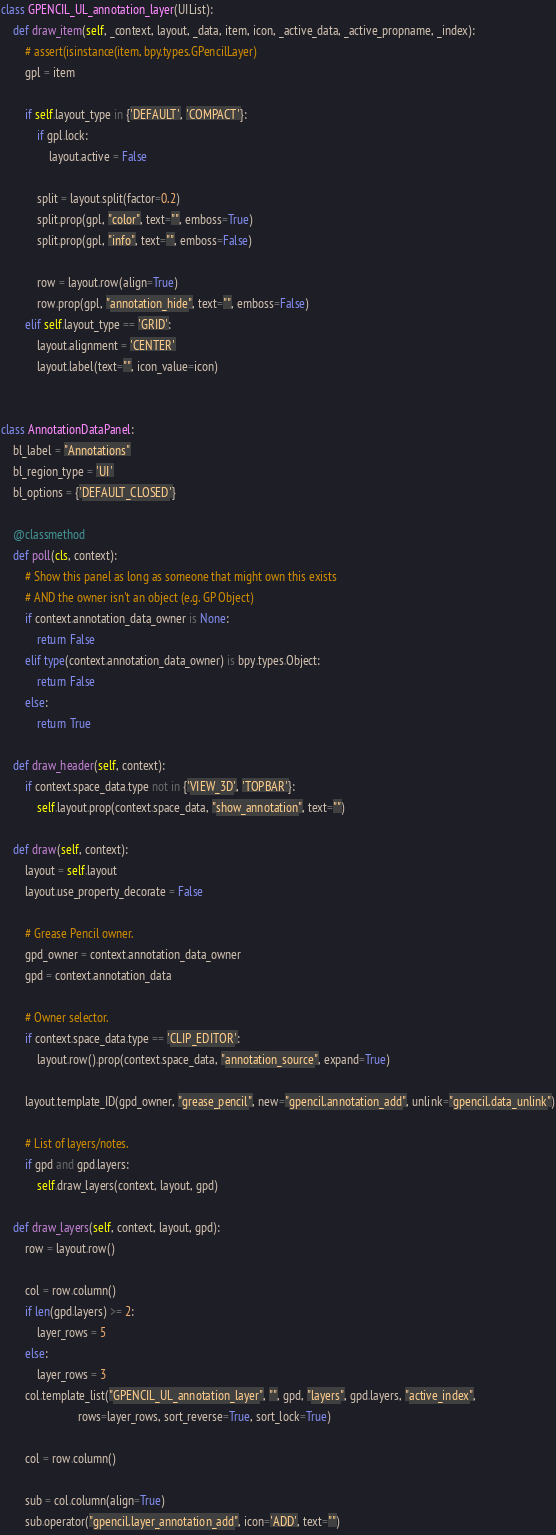<code> <loc_0><loc_0><loc_500><loc_500><_Python_>

class GPENCIL_UL_annotation_layer(UIList):
    def draw_item(self, _context, layout, _data, item, icon, _active_data, _active_propname, _index):
        # assert(isinstance(item, bpy.types.GPencilLayer)
        gpl = item

        if self.layout_type in {'DEFAULT', 'COMPACT'}:
            if gpl.lock:
                layout.active = False

            split = layout.split(factor=0.2)
            split.prop(gpl, "color", text="", emboss=True)
            split.prop(gpl, "info", text="", emboss=False)

            row = layout.row(align=True)
            row.prop(gpl, "annotation_hide", text="", emboss=False)
        elif self.layout_type == 'GRID':
            layout.alignment = 'CENTER'
            layout.label(text="", icon_value=icon)


class AnnotationDataPanel:
    bl_label = "Annotations"
    bl_region_type = 'UI'
    bl_options = {'DEFAULT_CLOSED'}

    @classmethod
    def poll(cls, context):
        # Show this panel as long as someone that might own this exists
        # AND the owner isn't an object (e.g. GP Object)
        if context.annotation_data_owner is None:
            return False
        elif type(context.annotation_data_owner) is bpy.types.Object:
            return False
        else:
            return True

    def draw_header(self, context):
        if context.space_data.type not in {'VIEW_3D', 'TOPBAR'}:
            self.layout.prop(context.space_data, "show_annotation", text="")

    def draw(self, context):
        layout = self.layout
        layout.use_property_decorate = False

        # Grease Pencil owner.
        gpd_owner = context.annotation_data_owner
        gpd = context.annotation_data

        # Owner selector.
        if context.space_data.type == 'CLIP_EDITOR':
            layout.row().prop(context.space_data, "annotation_source", expand=True)

        layout.template_ID(gpd_owner, "grease_pencil", new="gpencil.annotation_add", unlink="gpencil.data_unlink")

        # List of layers/notes.
        if gpd and gpd.layers:
            self.draw_layers(context, layout, gpd)

    def draw_layers(self, context, layout, gpd):
        row = layout.row()

        col = row.column()
        if len(gpd.layers) >= 2:
            layer_rows = 5
        else:
            layer_rows = 3
        col.template_list("GPENCIL_UL_annotation_layer", "", gpd, "layers", gpd.layers, "active_index",
                          rows=layer_rows, sort_reverse=True, sort_lock=True)

        col = row.column()

        sub = col.column(align=True)
        sub.operator("gpencil.layer_annotation_add", icon='ADD', text="")</code> 